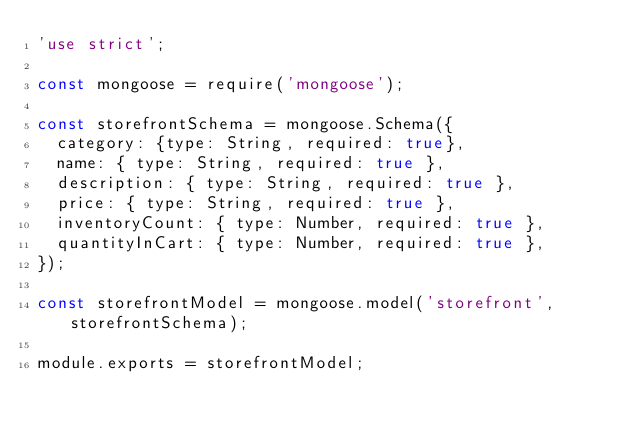<code> <loc_0><loc_0><loc_500><loc_500><_JavaScript_>'use strict';

const mongoose = require('mongoose');

const storefrontSchema = mongoose.Schema({
  category: {type: String, required: true},
  name: { type: String, required: true },
  description: { type: String, required: true },
  price: { type: String, required: true },
  inventoryCount: { type: Number, required: true },
  quantityInCart: { type: Number, required: true },
});

const storefrontModel = mongoose.model('storefront', storefrontSchema);

module.exports = storefrontModel;
</code> 